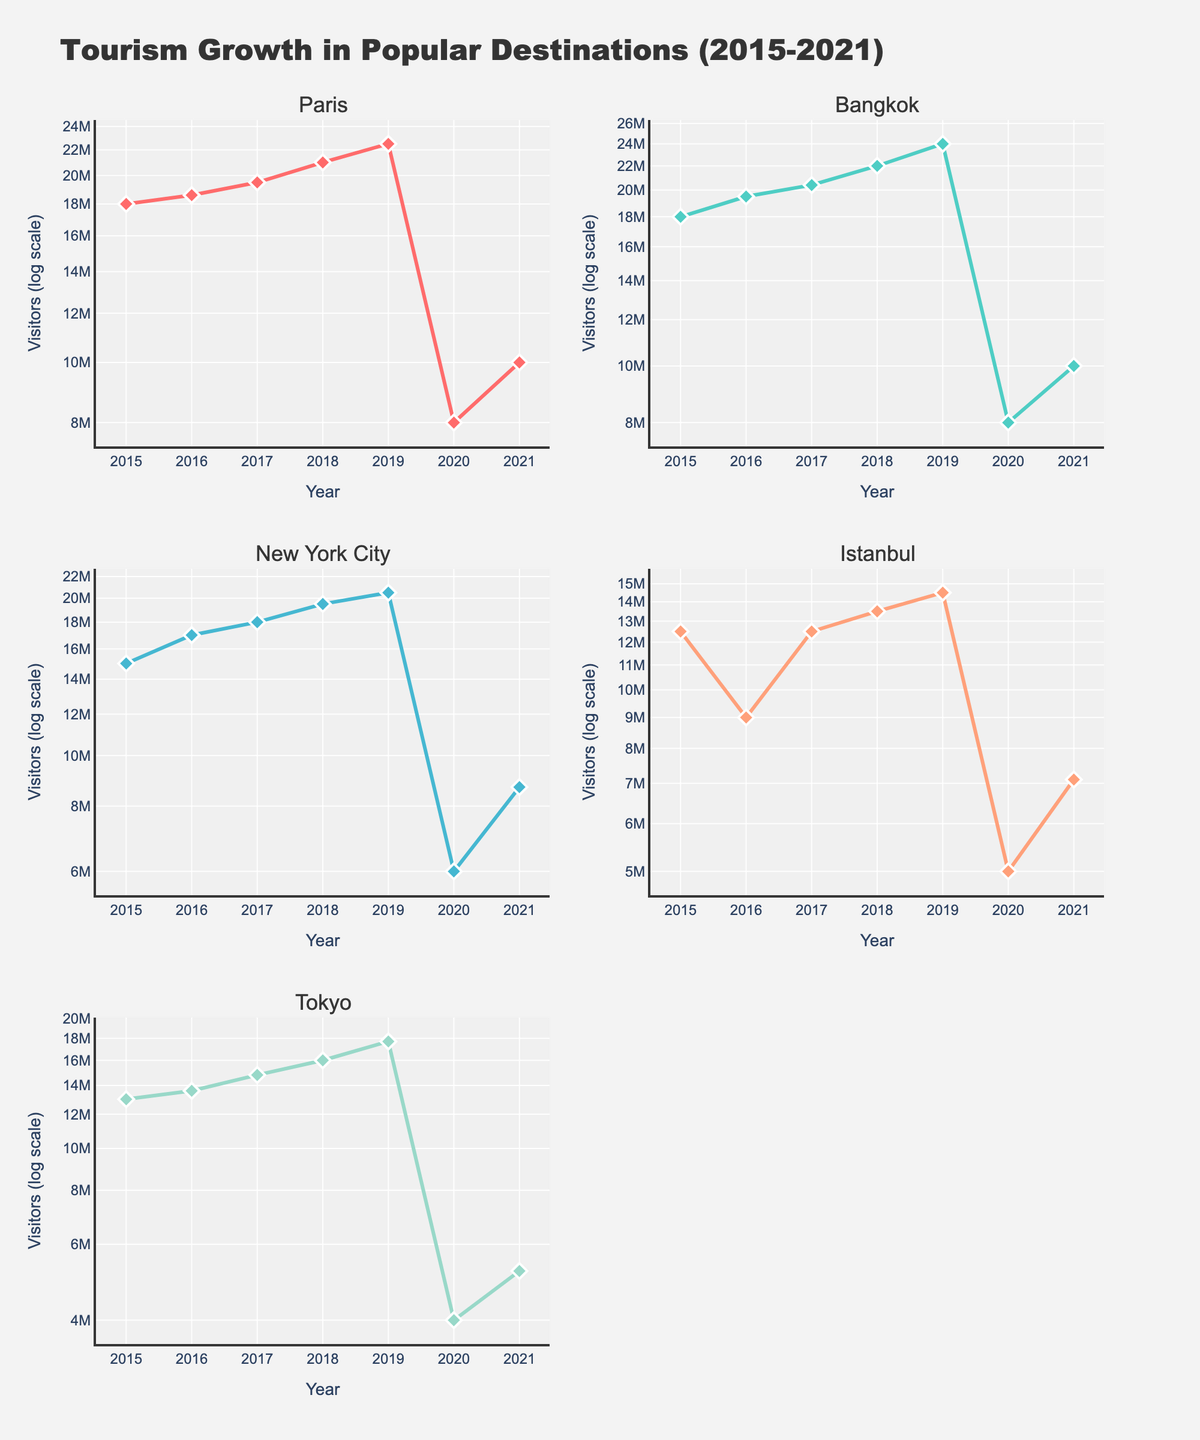What's the title of the figure? The title is located at the top of the figure.
Answer: Tourism Growth in Popular Destinations (2015-2021) How many destinations are compared in the figure? By looking at the subplot titles, there are five destinations.
Answer: Five What is the range of years displayed on the x-axis for each subplot? Every subplot has an x-axis labeled from 2015 to 2021.
Answer: 2015 to 2021 Which destination had the highest number of visitors in 2019? Inspecting the visitor counts for all destinations in 2019 shows that Bangkok has the highest visitor count.
Answer: Bangkok Between Paris and New York City, which destination had fewer visitors in 2020? Checking the visitor numbers for both destinations in 2020, Paris had 8,000,000 visitors while New York City had 6,000,000 visitors.
Answer: New York City What visual changes can you observe in the number of visitors for all destinations during 2020? All destinations show a significant drop in the number of visitors in 2020.
Answer: Significant drop Which destination exhibited the most noticeable recovery in 2021 compared to 2020? Comparing the difference in visitor numbers between 2020 and 2021, Paris increased from 8,000,000 to 10,000,000, a 25% increase, whereas Bangkok also increased from 8,000,000 to 10,000,000, but a closer examination shows similar trends for other destinations. Istanbul increased from 5,000,000 to 7,100,000 showing a 42% increase, making it the highest recovery.
Answer: Istanbul For Tokyo, how many visitors were there in 2015 compared to 2021? Looking at the subplot for Tokyo, in 2015 there were 13,000,000 visitors and in 2021, there were 5,200,000 visitors.
Answer: 13,000,000 in 2015 and 5,200,000 in 2021 Which destination had the least number of visitors in 2016? Inspection of the 2016 visitor numbers shows that Istanbul had the least with 9,000,000 visitors.
Answer: Istanbul 